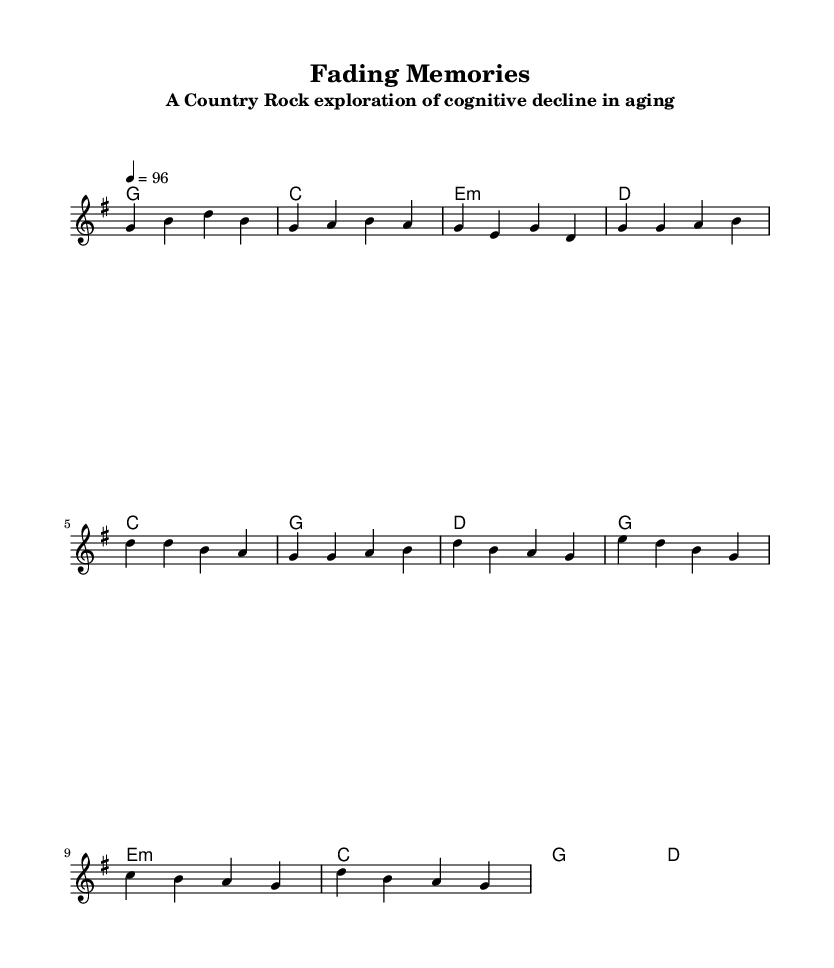What is the key signature of this music? The key signature is G major, which has one sharp (F#). This indicates that the music will primarily use G major chords and the notes of the G major scale.
Answer: G major What is the time signature of this piece? The time signature is 4/4, meaning there are four beats in each measure and the quarter note receives one beat. This is a common time signature in country rock music, which often has a steady rhythm.
Answer: 4/4 What is the tempo marking of the piece? The tempo marking is 96 beats per minute, which is indicated in the score. This suggests a moderate pace suitable for a country rock style, allowing for a comfortable sing-along feel.
Answer: 96 How many verses are there in the song? The song includes one verse, followed by a chorus and a bridge. The structure typically follows the pattern of verse, chorus, bridge, which is common in country rock songs.
Answer: One What are the characteristics of the chorus compared to the verse? The chorus is more repetitive and uplifting, featuring a simpler melody that is catchy and easy to remember, while the verse tells a more detailed story about fading memories. This contrast is typical in country rock, allowing for emotional resonance.
Answer: Uplifting and repetitive What emotion does the bridge convey compared to the rest of the song? The bridge conveys a moment of clarity and hope amidst the themes of cognitive decline, suggesting a brief resurgence in recollection. This emotional shift adds depth and complexity to the storytelling in the song.
Answer: Clarity and hope What is the primary theme explored in the song? The primary theme of the song is cognitive decline and the fading of memories in aging, expressed through the metaphor of pictures on a wall slowly fading. This theme is relevant to the emotional landscape of country music, which often deals with personal and reflective topics.
Answer: Cognitive decline 